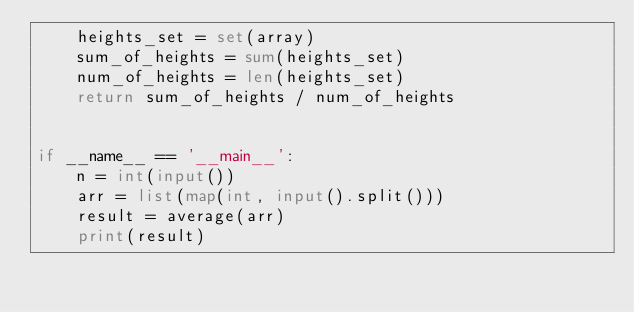<code> <loc_0><loc_0><loc_500><loc_500><_Python_>    heights_set = set(array)
    sum_of_heights = sum(heights_set)
    num_of_heights = len(heights_set)
    return sum_of_heights / num_of_heights


if __name__ == '__main__':
    n = int(input())
    arr = list(map(int, input().split()))
    result = average(arr)
    print(result)
</code> 